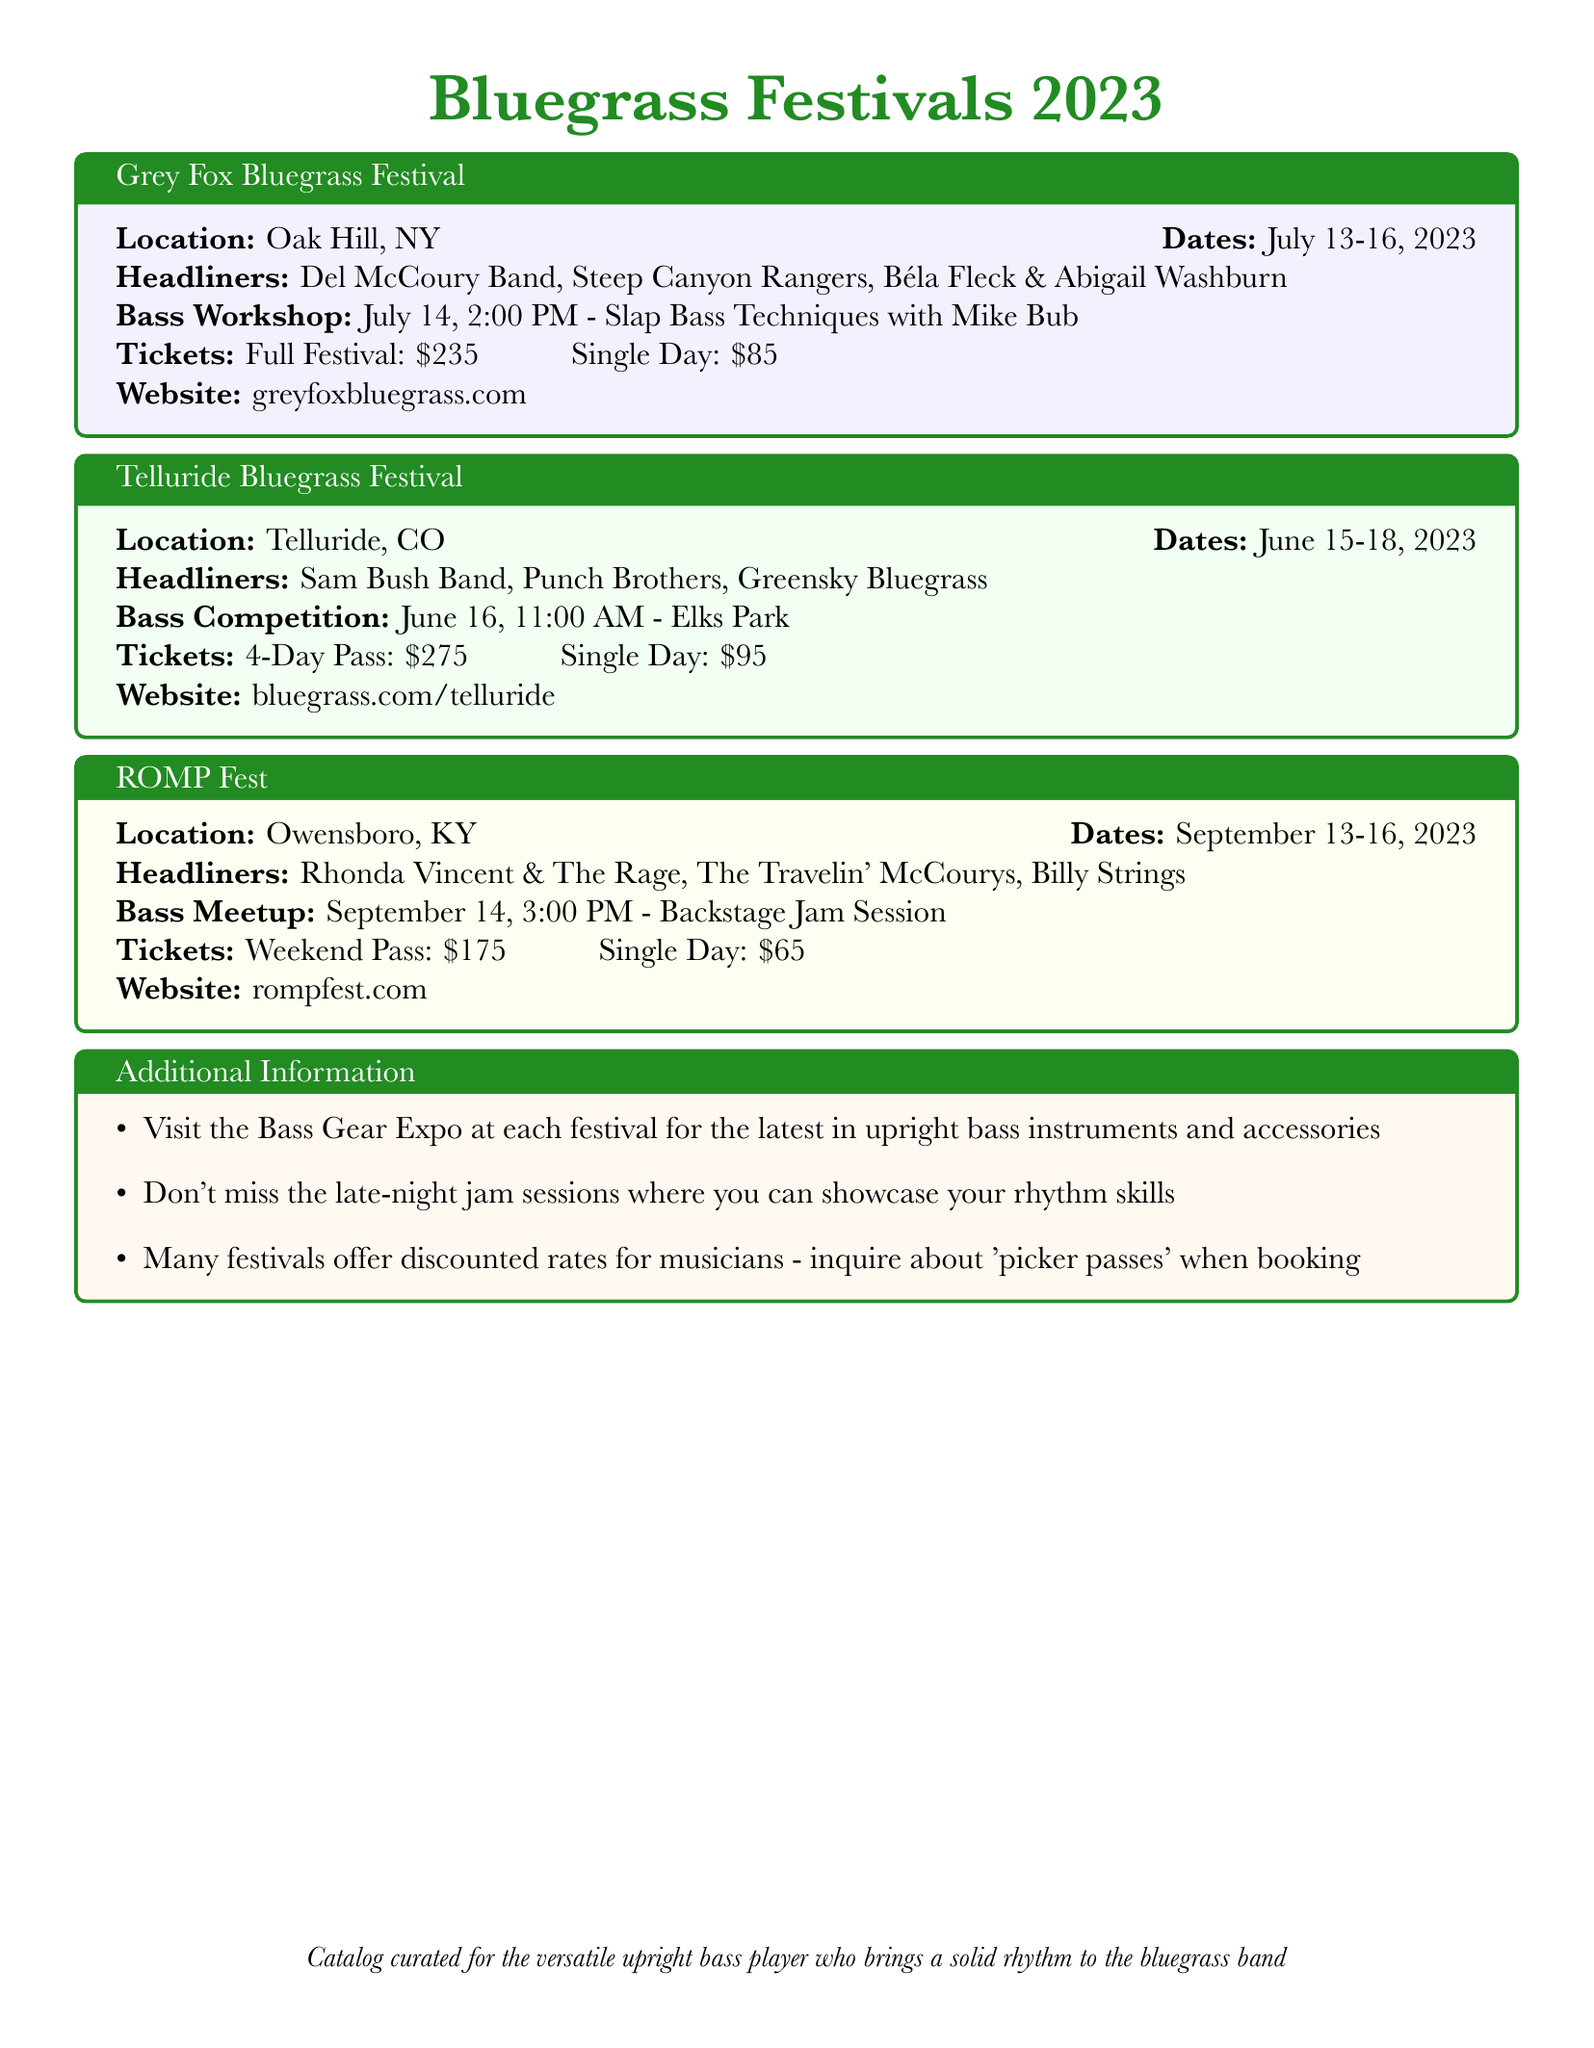What are the dates for the Grey Fox Bluegrass Festival? The dates for the Grey Fox Bluegrass Festival are found in the document and are July 13-16, 2023.
Answer: July 13-16, 2023 Who are the headliners for the Telluride Bluegrass Festival? The headliners for the Telluride Bluegrass Festival can be found in the document and include Sam Bush Band, Punch Brothers, and Greensky Bluegrass.
Answer: Sam Bush Band, Punch Brothers, Greensky Bluegrass When is the bass workshop at the Grey Fox Bluegrass Festival? The bass workshop details, including time and date, are listed in the document as July 14, 2:00 PM.
Answer: July 14, 2:00 PM How much is a weekend pass for ROMP Fest? The cost of a weekend pass for ROMP Fest is specified in the document as $175.
Answer: $175 What special event occurs on June 16 at the Telluride Bluegrass Festival? The document states an event occurring on June 16 is the bass competition at 11:00 AM.
Answer: Bass Competition What festival features a backstage jam session? The document indicates that ROMP Fest features a backstage jam session for bass players.
Answer: ROMP Fest Which festival takes place in Owensboro, KY? The location of the festival in Owensboro, KY is mentioned as ROMP Fest in the document.
Answer: ROMP Fest What is a 'picker pass'? The document refers to discounted rates for musicians under 'picker passes' as an inquiry when booking, indicating it is a special admission rate.
Answer: Special admission rate 